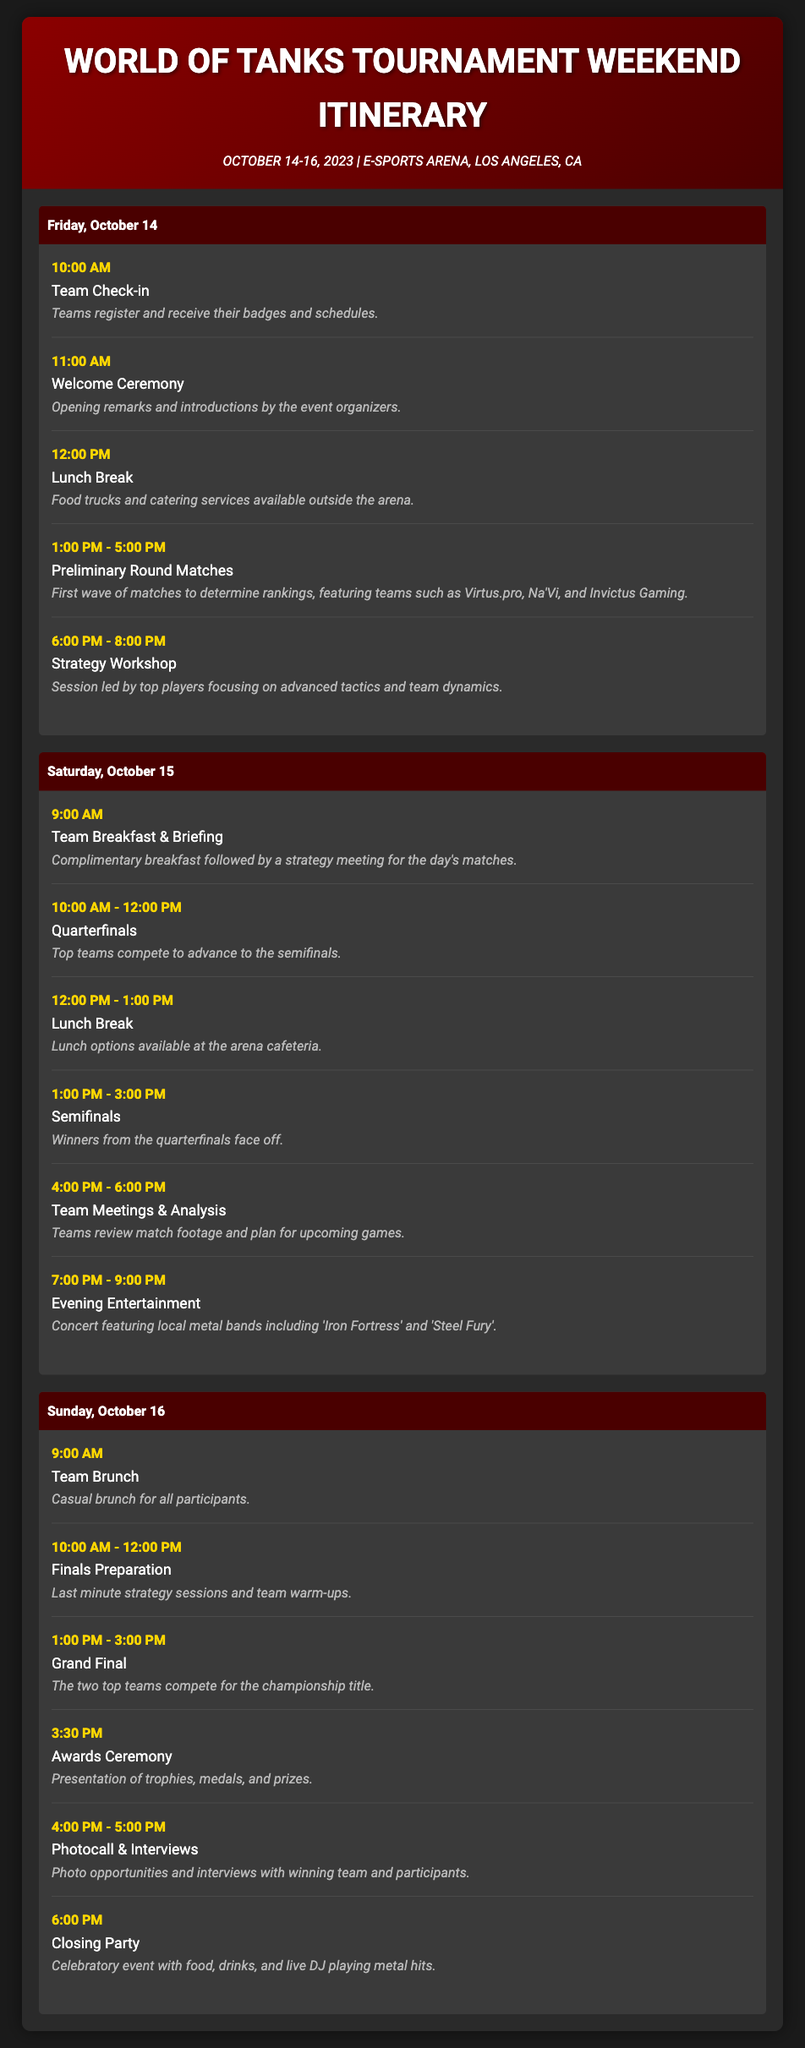What are the dates of the tournament? The document states that the tournament takes place from October 14 to October 16, 2023.
Answer: October 14-16, 2023 Where is the tournament held? The venue for the tournament is mentioned as E-SPORTS Arena, Los Angeles, CA.
Answer: E-SPORTS Arena, Los Angeles, CA What time does the Welcome Ceremony start? According to the itinerary, the Welcome Ceremony is scheduled to start at 11:00 AM on Friday, October 14.
Answer: 11:00 AM Which teams are mentioned in the Preliminary Round Matches? The document specifically lists Virtus.pro, Na'Vi, and Invictus Gaming as participants in the preliminary round matches.
Answer: Virtus.pro, Na'Vi, Invictus Gaming What is the title of the event scheduled at 7:00 PM on Saturday? The evening event listed for Saturday at 7:00 PM is the Evening Entertainment featuring local metal bands.
Answer: Evening Entertainment How long do the Quarterfinals last? The document states that the Quarterfinals take place from 10:00 AM to 12:00 PM, lasting for 2 hours.
Answer: 2 hours What activity is scheduled immediately after the Grand Final? The Awards Ceremony is the activity scheduled immediately after the Grand Final.
Answer: Awards Ceremony What is featured at the Closing Party? The Closing Party is described as a celebratory event with food, drinks, and live DJ playing metal hits.
Answer: Food, drinks, and live DJ playing metal hits 